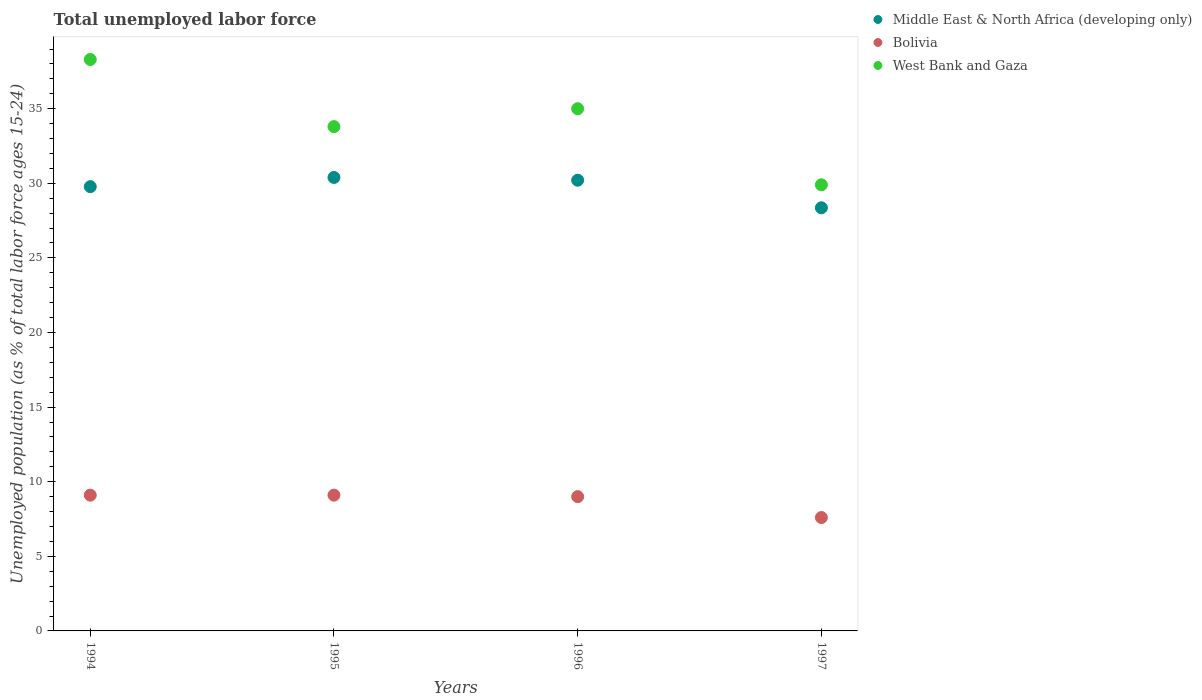Is the number of dotlines equal to the number of legend labels?
Give a very brief answer. Yes. What is the percentage of unemployed population in in Bolivia in 1997?
Keep it short and to the point. 7.6. Across all years, what is the maximum percentage of unemployed population in in West Bank and Gaza?
Keep it short and to the point. 38.3. Across all years, what is the minimum percentage of unemployed population in in West Bank and Gaza?
Offer a very short reply. 29.9. What is the total percentage of unemployed population in in Middle East & North Africa (developing only) in the graph?
Provide a short and direct response. 118.74. What is the difference between the percentage of unemployed population in in West Bank and Gaza in 1996 and that in 1997?
Provide a succinct answer. 5.1. What is the difference between the percentage of unemployed population in in West Bank and Gaza in 1995 and the percentage of unemployed population in in Middle East & North Africa (developing only) in 1997?
Provide a short and direct response. 5.44. What is the average percentage of unemployed population in in West Bank and Gaza per year?
Provide a short and direct response. 34.25. In the year 1997, what is the difference between the percentage of unemployed population in in Middle East & North Africa (developing only) and percentage of unemployed population in in West Bank and Gaza?
Keep it short and to the point. -1.54. In how many years, is the percentage of unemployed population in in Bolivia greater than 6 %?
Your response must be concise. 4. What is the ratio of the percentage of unemployed population in in Bolivia in 1994 to that in 1997?
Ensure brevity in your answer.  1.2. What is the difference between the highest and the lowest percentage of unemployed population in in Bolivia?
Ensure brevity in your answer.  1.5. In how many years, is the percentage of unemployed population in in West Bank and Gaza greater than the average percentage of unemployed population in in West Bank and Gaza taken over all years?
Ensure brevity in your answer.  2. Is the sum of the percentage of unemployed population in in West Bank and Gaza in 1994 and 1996 greater than the maximum percentage of unemployed population in in Bolivia across all years?
Your response must be concise. Yes. How many dotlines are there?
Keep it short and to the point. 3. How many years are there in the graph?
Your answer should be very brief. 4. What is the difference between two consecutive major ticks on the Y-axis?
Provide a succinct answer. 5. Are the values on the major ticks of Y-axis written in scientific E-notation?
Your answer should be compact. No. Does the graph contain any zero values?
Your answer should be compact. No. How are the legend labels stacked?
Give a very brief answer. Vertical. What is the title of the graph?
Ensure brevity in your answer.  Total unemployed labor force. Does "Turks and Caicos Islands" appear as one of the legend labels in the graph?
Keep it short and to the point. No. What is the label or title of the Y-axis?
Your answer should be very brief. Unemployed population (as % of total labor force ages 15-24). What is the Unemployed population (as % of total labor force ages 15-24) in Middle East & North Africa (developing only) in 1994?
Your answer should be very brief. 29.78. What is the Unemployed population (as % of total labor force ages 15-24) in Bolivia in 1994?
Make the answer very short. 9.1. What is the Unemployed population (as % of total labor force ages 15-24) of West Bank and Gaza in 1994?
Give a very brief answer. 38.3. What is the Unemployed population (as % of total labor force ages 15-24) of Middle East & North Africa (developing only) in 1995?
Provide a short and direct response. 30.39. What is the Unemployed population (as % of total labor force ages 15-24) of Bolivia in 1995?
Provide a succinct answer. 9.1. What is the Unemployed population (as % of total labor force ages 15-24) in West Bank and Gaza in 1995?
Your answer should be compact. 33.8. What is the Unemployed population (as % of total labor force ages 15-24) of Middle East & North Africa (developing only) in 1996?
Keep it short and to the point. 30.21. What is the Unemployed population (as % of total labor force ages 15-24) in Bolivia in 1996?
Offer a very short reply. 9. What is the Unemployed population (as % of total labor force ages 15-24) in Middle East & North Africa (developing only) in 1997?
Offer a very short reply. 28.36. What is the Unemployed population (as % of total labor force ages 15-24) of Bolivia in 1997?
Offer a terse response. 7.6. What is the Unemployed population (as % of total labor force ages 15-24) of West Bank and Gaza in 1997?
Offer a very short reply. 29.9. Across all years, what is the maximum Unemployed population (as % of total labor force ages 15-24) in Middle East & North Africa (developing only)?
Keep it short and to the point. 30.39. Across all years, what is the maximum Unemployed population (as % of total labor force ages 15-24) in Bolivia?
Keep it short and to the point. 9.1. Across all years, what is the maximum Unemployed population (as % of total labor force ages 15-24) in West Bank and Gaza?
Your answer should be very brief. 38.3. Across all years, what is the minimum Unemployed population (as % of total labor force ages 15-24) of Middle East & North Africa (developing only)?
Offer a terse response. 28.36. Across all years, what is the minimum Unemployed population (as % of total labor force ages 15-24) in Bolivia?
Make the answer very short. 7.6. Across all years, what is the minimum Unemployed population (as % of total labor force ages 15-24) in West Bank and Gaza?
Your answer should be compact. 29.9. What is the total Unemployed population (as % of total labor force ages 15-24) in Middle East & North Africa (developing only) in the graph?
Keep it short and to the point. 118.74. What is the total Unemployed population (as % of total labor force ages 15-24) in Bolivia in the graph?
Your answer should be compact. 34.8. What is the total Unemployed population (as % of total labor force ages 15-24) in West Bank and Gaza in the graph?
Provide a short and direct response. 137. What is the difference between the Unemployed population (as % of total labor force ages 15-24) of Middle East & North Africa (developing only) in 1994 and that in 1995?
Ensure brevity in your answer.  -0.62. What is the difference between the Unemployed population (as % of total labor force ages 15-24) in Bolivia in 1994 and that in 1995?
Your answer should be compact. 0. What is the difference between the Unemployed population (as % of total labor force ages 15-24) in West Bank and Gaza in 1994 and that in 1995?
Provide a short and direct response. 4.5. What is the difference between the Unemployed population (as % of total labor force ages 15-24) of Middle East & North Africa (developing only) in 1994 and that in 1996?
Ensure brevity in your answer.  -0.43. What is the difference between the Unemployed population (as % of total labor force ages 15-24) of West Bank and Gaza in 1994 and that in 1996?
Your answer should be very brief. 3.3. What is the difference between the Unemployed population (as % of total labor force ages 15-24) of Middle East & North Africa (developing only) in 1994 and that in 1997?
Your answer should be very brief. 1.42. What is the difference between the Unemployed population (as % of total labor force ages 15-24) in Bolivia in 1994 and that in 1997?
Your response must be concise. 1.5. What is the difference between the Unemployed population (as % of total labor force ages 15-24) in West Bank and Gaza in 1994 and that in 1997?
Keep it short and to the point. 8.4. What is the difference between the Unemployed population (as % of total labor force ages 15-24) of Middle East & North Africa (developing only) in 1995 and that in 1996?
Keep it short and to the point. 0.18. What is the difference between the Unemployed population (as % of total labor force ages 15-24) in Bolivia in 1995 and that in 1996?
Offer a very short reply. 0.1. What is the difference between the Unemployed population (as % of total labor force ages 15-24) of West Bank and Gaza in 1995 and that in 1996?
Your answer should be very brief. -1.2. What is the difference between the Unemployed population (as % of total labor force ages 15-24) in Middle East & North Africa (developing only) in 1995 and that in 1997?
Ensure brevity in your answer.  2.03. What is the difference between the Unemployed population (as % of total labor force ages 15-24) in Bolivia in 1995 and that in 1997?
Give a very brief answer. 1.5. What is the difference between the Unemployed population (as % of total labor force ages 15-24) in Middle East & North Africa (developing only) in 1996 and that in 1997?
Give a very brief answer. 1.85. What is the difference between the Unemployed population (as % of total labor force ages 15-24) of Bolivia in 1996 and that in 1997?
Your answer should be very brief. 1.4. What is the difference between the Unemployed population (as % of total labor force ages 15-24) in Middle East & North Africa (developing only) in 1994 and the Unemployed population (as % of total labor force ages 15-24) in Bolivia in 1995?
Keep it short and to the point. 20.68. What is the difference between the Unemployed population (as % of total labor force ages 15-24) in Middle East & North Africa (developing only) in 1994 and the Unemployed population (as % of total labor force ages 15-24) in West Bank and Gaza in 1995?
Your answer should be very brief. -4.02. What is the difference between the Unemployed population (as % of total labor force ages 15-24) of Bolivia in 1994 and the Unemployed population (as % of total labor force ages 15-24) of West Bank and Gaza in 1995?
Ensure brevity in your answer.  -24.7. What is the difference between the Unemployed population (as % of total labor force ages 15-24) of Middle East & North Africa (developing only) in 1994 and the Unemployed population (as % of total labor force ages 15-24) of Bolivia in 1996?
Provide a succinct answer. 20.78. What is the difference between the Unemployed population (as % of total labor force ages 15-24) in Middle East & North Africa (developing only) in 1994 and the Unemployed population (as % of total labor force ages 15-24) in West Bank and Gaza in 1996?
Offer a terse response. -5.22. What is the difference between the Unemployed population (as % of total labor force ages 15-24) in Bolivia in 1994 and the Unemployed population (as % of total labor force ages 15-24) in West Bank and Gaza in 1996?
Make the answer very short. -25.9. What is the difference between the Unemployed population (as % of total labor force ages 15-24) of Middle East & North Africa (developing only) in 1994 and the Unemployed population (as % of total labor force ages 15-24) of Bolivia in 1997?
Give a very brief answer. 22.18. What is the difference between the Unemployed population (as % of total labor force ages 15-24) of Middle East & North Africa (developing only) in 1994 and the Unemployed population (as % of total labor force ages 15-24) of West Bank and Gaza in 1997?
Ensure brevity in your answer.  -0.12. What is the difference between the Unemployed population (as % of total labor force ages 15-24) in Bolivia in 1994 and the Unemployed population (as % of total labor force ages 15-24) in West Bank and Gaza in 1997?
Your answer should be compact. -20.8. What is the difference between the Unemployed population (as % of total labor force ages 15-24) in Middle East & North Africa (developing only) in 1995 and the Unemployed population (as % of total labor force ages 15-24) in Bolivia in 1996?
Keep it short and to the point. 21.39. What is the difference between the Unemployed population (as % of total labor force ages 15-24) of Middle East & North Africa (developing only) in 1995 and the Unemployed population (as % of total labor force ages 15-24) of West Bank and Gaza in 1996?
Give a very brief answer. -4.61. What is the difference between the Unemployed population (as % of total labor force ages 15-24) in Bolivia in 1995 and the Unemployed population (as % of total labor force ages 15-24) in West Bank and Gaza in 1996?
Keep it short and to the point. -25.9. What is the difference between the Unemployed population (as % of total labor force ages 15-24) in Middle East & North Africa (developing only) in 1995 and the Unemployed population (as % of total labor force ages 15-24) in Bolivia in 1997?
Make the answer very short. 22.79. What is the difference between the Unemployed population (as % of total labor force ages 15-24) of Middle East & North Africa (developing only) in 1995 and the Unemployed population (as % of total labor force ages 15-24) of West Bank and Gaza in 1997?
Provide a short and direct response. 0.49. What is the difference between the Unemployed population (as % of total labor force ages 15-24) in Bolivia in 1995 and the Unemployed population (as % of total labor force ages 15-24) in West Bank and Gaza in 1997?
Ensure brevity in your answer.  -20.8. What is the difference between the Unemployed population (as % of total labor force ages 15-24) in Middle East & North Africa (developing only) in 1996 and the Unemployed population (as % of total labor force ages 15-24) in Bolivia in 1997?
Your answer should be compact. 22.61. What is the difference between the Unemployed population (as % of total labor force ages 15-24) of Middle East & North Africa (developing only) in 1996 and the Unemployed population (as % of total labor force ages 15-24) of West Bank and Gaza in 1997?
Make the answer very short. 0.31. What is the difference between the Unemployed population (as % of total labor force ages 15-24) of Bolivia in 1996 and the Unemployed population (as % of total labor force ages 15-24) of West Bank and Gaza in 1997?
Provide a succinct answer. -20.9. What is the average Unemployed population (as % of total labor force ages 15-24) of Middle East & North Africa (developing only) per year?
Your response must be concise. 29.68. What is the average Unemployed population (as % of total labor force ages 15-24) in West Bank and Gaza per year?
Keep it short and to the point. 34.25. In the year 1994, what is the difference between the Unemployed population (as % of total labor force ages 15-24) in Middle East & North Africa (developing only) and Unemployed population (as % of total labor force ages 15-24) in Bolivia?
Ensure brevity in your answer.  20.68. In the year 1994, what is the difference between the Unemployed population (as % of total labor force ages 15-24) in Middle East & North Africa (developing only) and Unemployed population (as % of total labor force ages 15-24) in West Bank and Gaza?
Your answer should be very brief. -8.52. In the year 1994, what is the difference between the Unemployed population (as % of total labor force ages 15-24) in Bolivia and Unemployed population (as % of total labor force ages 15-24) in West Bank and Gaza?
Your answer should be very brief. -29.2. In the year 1995, what is the difference between the Unemployed population (as % of total labor force ages 15-24) in Middle East & North Africa (developing only) and Unemployed population (as % of total labor force ages 15-24) in Bolivia?
Provide a short and direct response. 21.29. In the year 1995, what is the difference between the Unemployed population (as % of total labor force ages 15-24) in Middle East & North Africa (developing only) and Unemployed population (as % of total labor force ages 15-24) in West Bank and Gaza?
Keep it short and to the point. -3.41. In the year 1995, what is the difference between the Unemployed population (as % of total labor force ages 15-24) of Bolivia and Unemployed population (as % of total labor force ages 15-24) of West Bank and Gaza?
Ensure brevity in your answer.  -24.7. In the year 1996, what is the difference between the Unemployed population (as % of total labor force ages 15-24) in Middle East & North Africa (developing only) and Unemployed population (as % of total labor force ages 15-24) in Bolivia?
Provide a short and direct response. 21.21. In the year 1996, what is the difference between the Unemployed population (as % of total labor force ages 15-24) in Middle East & North Africa (developing only) and Unemployed population (as % of total labor force ages 15-24) in West Bank and Gaza?
Give a very brief answer. -4.79. In the year 1996, what is the difference between the Unemployed population (as % of total labor force ages 15-24) of Bolivia and Unemployed population (as % of total labor force ages 15-24) of West Bank and Gaza?
Keep it short and to the point. -26. In the year 1997, what is the difference between the Unemployed population (as % of total labor force ages 15-24) in Middle East & North Africa (developing only) and Unemployed population (as % of total labor force ages 15-24) in Bolivia?
Ensure brevity in your answer.  20.76. In the year 1997, what is the difference between the Unemployed population (as % of total labor force ages 15-24) in Middle East & North Africa (developing only) and Unemployed population (as % of total labor force ages 15-24) in West Bank and Gaza?
Make the answer very short. -1.54. In the year 1997, what is the difference between the Unemployed population (as % of total labor force ages 15-24) in Bolivia and Unemployed population (as % of total labor force ages 15-24) in West Bank and Gaza?
Make the answer very short. -22.3. What is the ratio of the Unemployed population (as % of total labor force ages 15-24) in Middle East & North Africa (developing only) in 1994 to that in 1995?
Your answer should be compact. 0.98. What is the ratio of the Unemployed population (as % of total labor force ages 15-24) of Bolivia in 1994 to that in 1995?
Make the answer very short. 1. What is the ratio of the Unemployed population (as % of total labor force ages 15-24) of West Bank and Gaza in 1994 to that in 1995?
Your answer should be compact. 1.13. What is the ratio of the Unemployed population (as % of total labor force ages 15-24) of Middle East & North Africa (developing only) in 1994 to that in 1996?
Offer a very short reply. 0.99. What is the ratio of the Unemployed population (as % of total labor force ages 15-24) in Bolivia in 1994 to that in 1996?
Give a very brief answer. 1.01. What is the ratio of the Unemployed population (as % of total labor force ages 15-24) in West Bank and Gaza in 1994 to that in 1996?
Ensure brevity in your answer.  1.09. What is the ratio of the Unemployed population (as % of total labor force ages 15-24) of Middle East & North Africa (developing only) in 1994 to that in 1997?
Provide a short and direct response. 1.05. What is the ratio of the Unemployed population (as % of total labor force ages 15-24) in Bolivia in 1994 to that in 1997?
Your response must be concise. 1.2. What is the ratio of the Unemployed population (as % of total labor force ages 15-24) of West Bank and Gaza in 1994 to that in 1997?
Provide a short and direct response. 1.28. What is the ratio of the Unemployed population (as % of total labor force ages 15-24) of Bolivia in 1995 to that in 1996?
Give a very brief answer. 1.01. What is the ratio of the Unemployed population (as % of total labor force ages 15-24) in West Bank and Gaza in 1995 to that in 1996?
Your answer should be very brief. 0.97. What is the ratio of the Unemployed population (as % of total labor force ages 15-24) of Middle East & North Africa (developing only) in 1995 to that in 1997?
Your answer should be compact. 1.07. What is the ratio of the Unemployed population (as % of total labor force ages 15-24) in Bolivia in 1995 to that in 1997?
Provide a short and direct response. 1.2. What is the ratio of the Unemployed population (as % of total labor force ages 15-24) in West Bank and Gaza in 1995 to that in 1997?
Keep it short and to the point. 1.13. What is the ratio of the Unemployed population (as % of total labor force ages 15-24) in Middle East & North Africa (developing only) in 1996 to that in 1997?
Offer a terse response. 1.07. What is the ratio of the Unemployed population (as % of total labor force ages 15-24) of Bolivia in 1996 to that in 1997?
Offer a very short reply. 1.18. What is the ratio of the Unemployed population (as % of total labor force ages 15-24) of West Bank and Gaza in 1996 to that in 1997?
Provide a short and direct response. 1.17. What is the difference between the highest and the second highest Unemployed population (as % of total labor force ages 15-24) of Middle East & North Africa (developing only)?
Give a very brief answer. 0.18. What is the difference between the highest and the second highest Unemployed population (as % of total labor force ages 15-24) in Bolivia?
Give a very brief answer. 0. What is the difference between the highest and the second highest Unemployed population (as % of total labor force ages 15-24) of West Bank and Gaza?
Ensure brevity in your answer.  3.3. What is the difference between the highest and the lowest Unemployed population (as % of total labor force ages 15-24) of Middle East & North Africa (developing only)?
Make the answer very short. 2.03. 